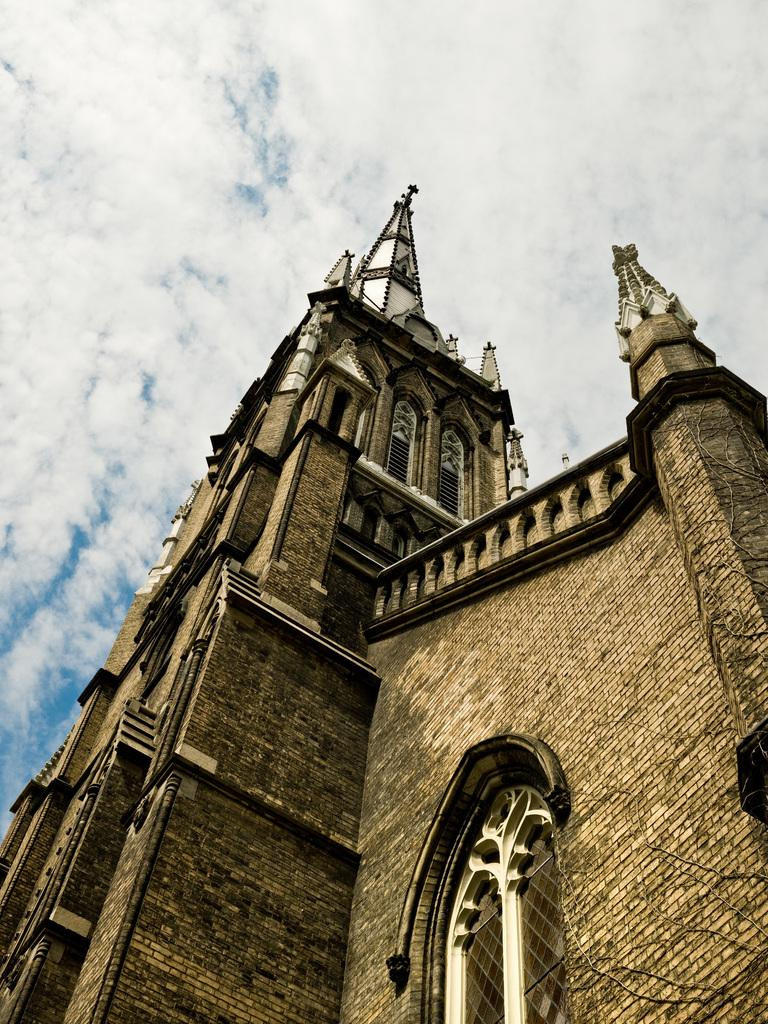What type of structure is visible in the image? There is a building in the image. What material is the building made of? The building is made up of stone bricks. What is the condition of the sky in the image? The sky is cloudy in the image. What sound can be heard coming from the building in the image? There is no sound present in the image, as it is a still photograph. 